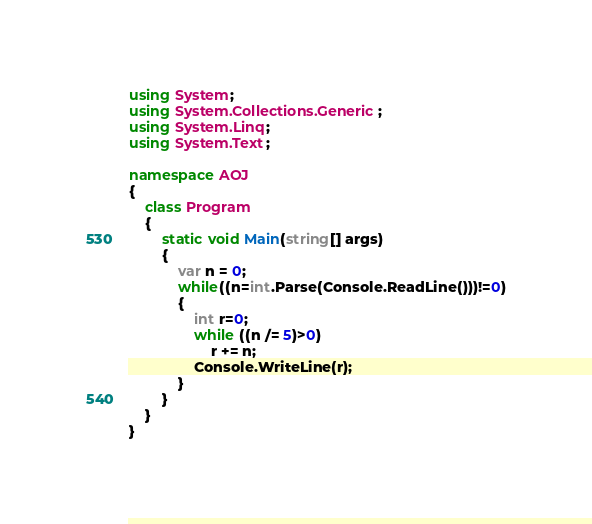Convert code to text. <code><loc_0><loc_0><loc_500><loc_500><_C#_>using System;
using System.Collections.Generic;
using System.Linq;
using System.Text;

namespace AOJ
{
	class Program
	{
		static void Main(string[] args)
		{
			var n = 0;
			while((n=int.Parse(Console.ReadLine()))!=0)
			{
				int r=0;
				while ((n /= 5)>0)
					r += n;
				Console.WriteLine(r);
			}
		}
	}
}</code> 